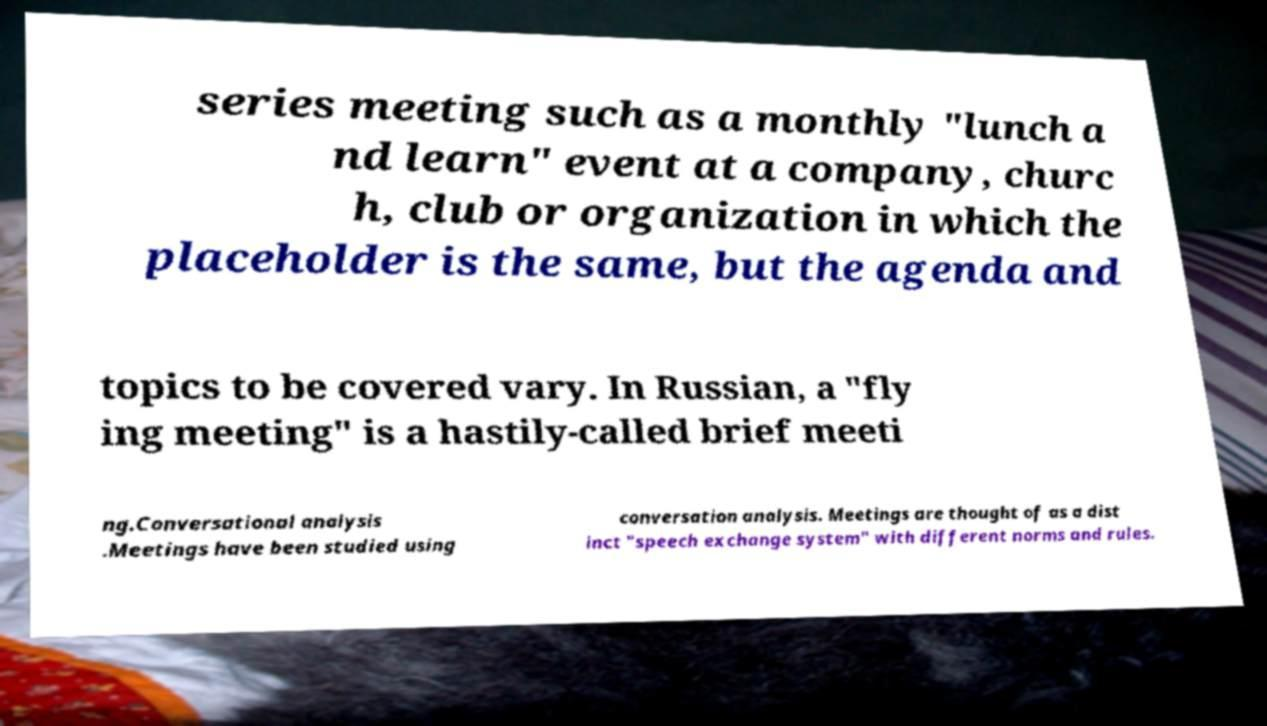Could you extract and type out the text from this image? series meeting such as a monthly "lunch a nd learn" event at a company, churc h, club or organization in which the placeholder is the same, but the agenda and topics to be covered vary. In Russian, a "fly ing meeting" is a hastily-called brief meeti ng.Conversational analysis .Meetings have been studied using conversation analysis. Meetings are thought of as a dist inct "speech exchange system" with different norms and rules. 